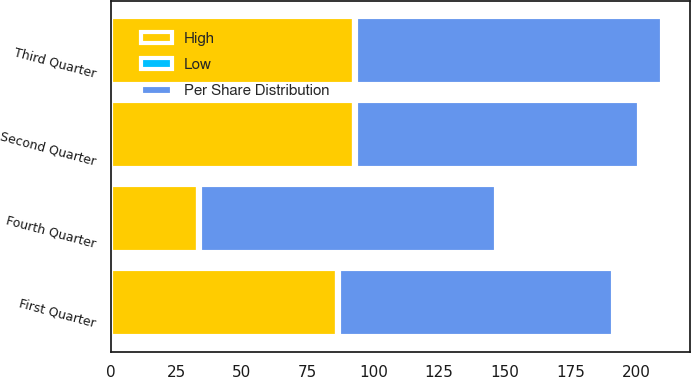<chart> <loc_0><loc_0><loc_500><loc_500><stacked_bar_chart><ecel><fcel>Fourth Quarter<fcel>Third Quarter<fcel>Second Quarter<fcel>First Quarter<nl><fcel>Per Share Distribution<fcel>112.72<fcel>116.5<fcel>107.5<fcel>104.23<nl><fcel>High<fcel>33.12<fcel>92.55<fcel>92.73<fcel>85.97<nl><fcel>Low<fcel>0.8<fcel>0.8<fcel>0.8<fcel>0.78<nl></chart> 